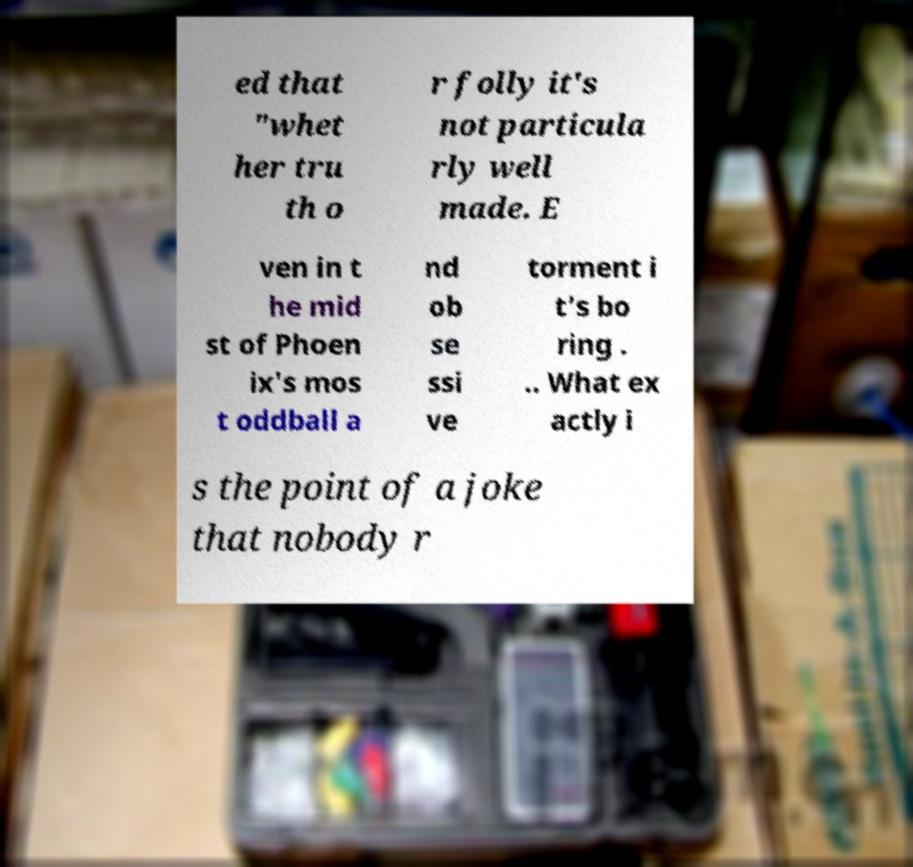For documentation purposes, I need the text within this image transcribed. Could you provide that? ed that "whet her tru th o r folly it's not particula rly well made. E ven in t he mid st of Phoen ix's mos t oddball a nd ob se ssi ve torment i t's bo ring . .. What ex actly i s the point of a joke that nobody r 